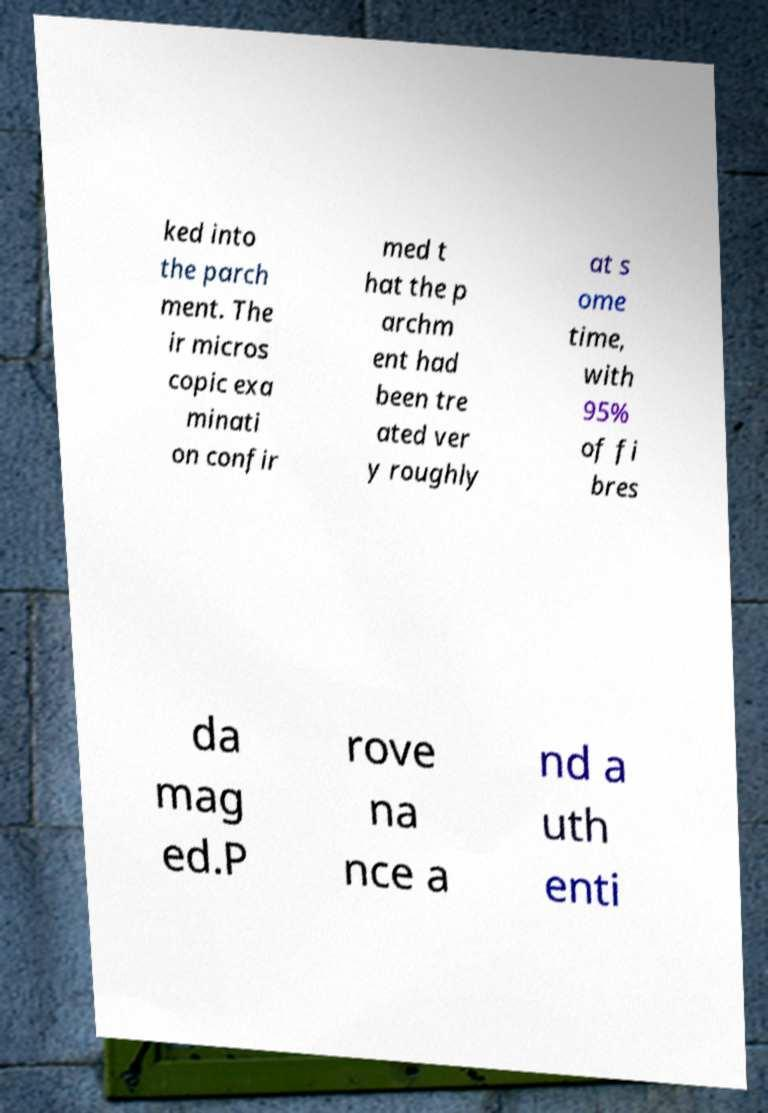Could you assist in decoding the text presented in this image and type it out clearly? ked into the parch ment. The ir micros copic exa minati on confir med t hat the p archm ent had been tre ated ver y roughly at s ome time, with 95% of fi bres da mag ed.P rove na nce a nd a uth enti 